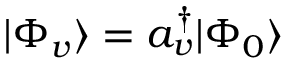Convert formula to latex. <formula><loc_0><loc_0><loc_500><loc_500>| \Phi _ { v } \rangle = a _ { v } ^ { \dagger } | \Phi _ { 0 } \rangle</formula> 